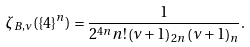Convert formula to latex. <formula><loc_0><loc_0><loc_500><loc_500>\zeta _ { B , \nu } ( \{ 4 \} ^ { n } ) = \frac { 1 } { 2 ^ { 4 n } n ! \left ( \nu + 1 \right ) _ { 2 n } \left ( \nu + 1 \right ) _ { n } } .</formula> 